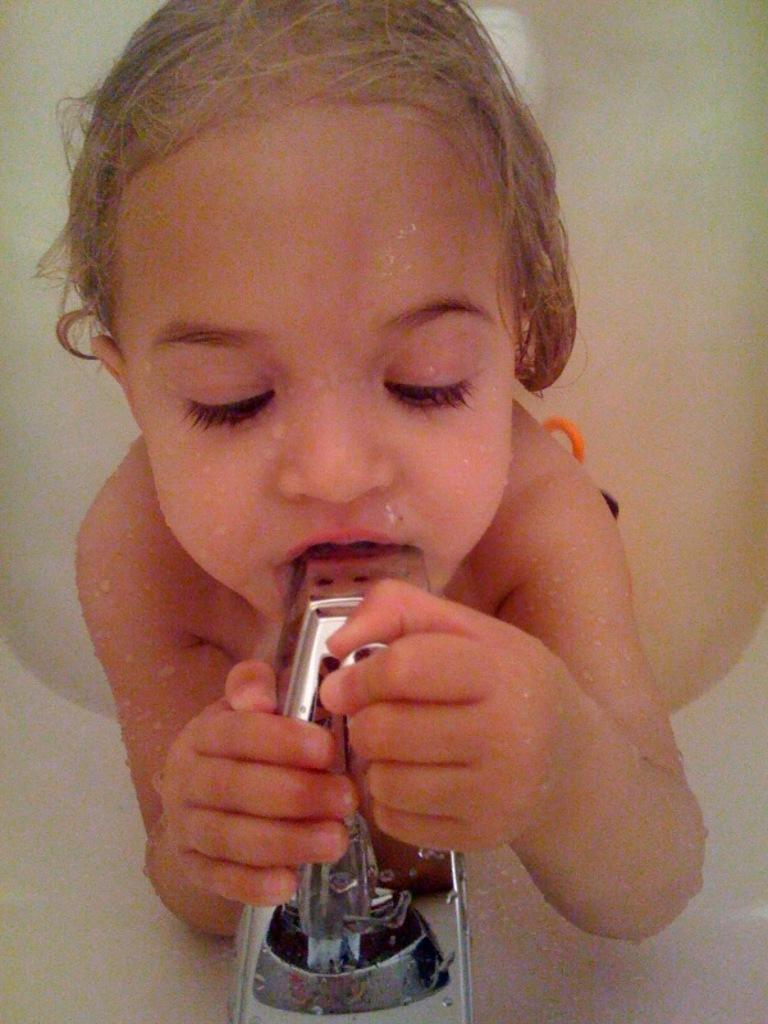What is the main subject of the image? The main subject of the image is a baby. What is the baby doing in the image? The baby is holding a tap with their hands and their mouth is also touching the tap. How many months old is the baby in the image? The provided facts do not mention the age of the baby, so it cannot be determined from the image. What type of trick is the baby performing with their toes in the image? There is no indication in the image that the baby is performing any tricks, and their toes are not visible in the image. 